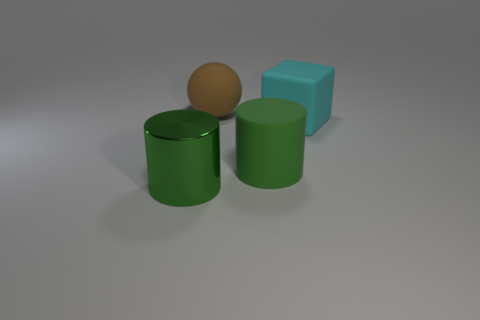Add 4 large shiny things. How many objects exist? 8 Subtract all blocks. How many objects are left? 3 Add 4 matte things. How many matte things are left? 7 Add 4 big metal cylinders. How many big metal cylinders exist? 5 Subtract 0 purple cylinders. How many objects are left? 4 Subtract all tiny purple cylinders. Subtract all large cubes. How many objects are left? 3 